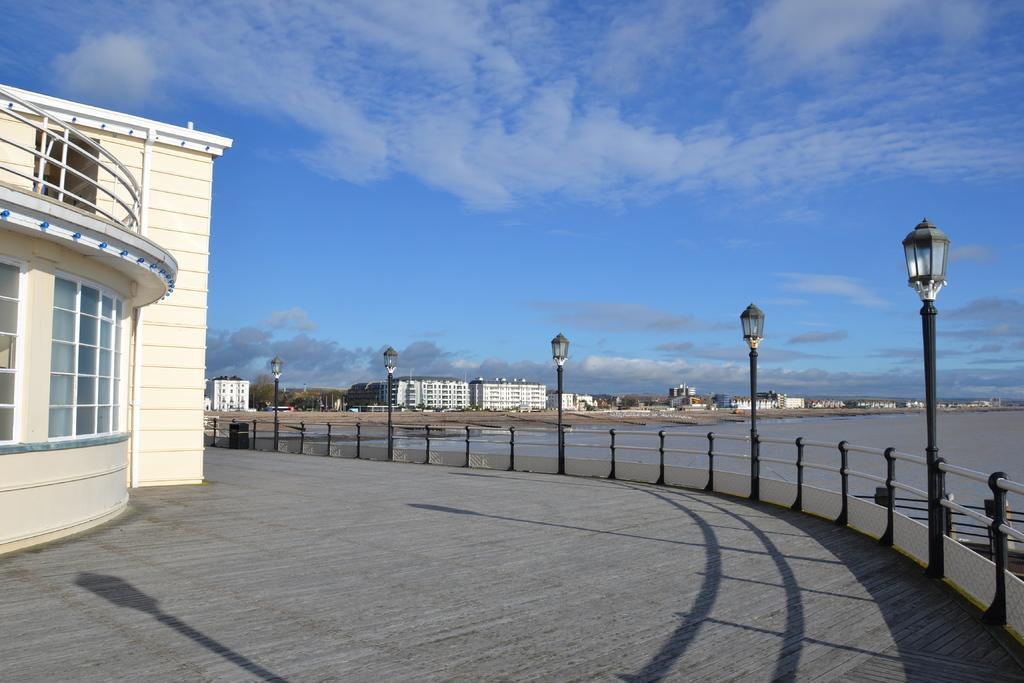How would you summarize this image in a sentence or two? This picture is clicked outside the city. At the bottom of the picture, we see a road. Beside that, we see an iron railing and the street lights. Beside that, we see water. On the left side, we see a building in white color. We even see windows. There are many buildings and trees in the background. At the top of the picture, we see the clouds and the sky, which is blue in color. 